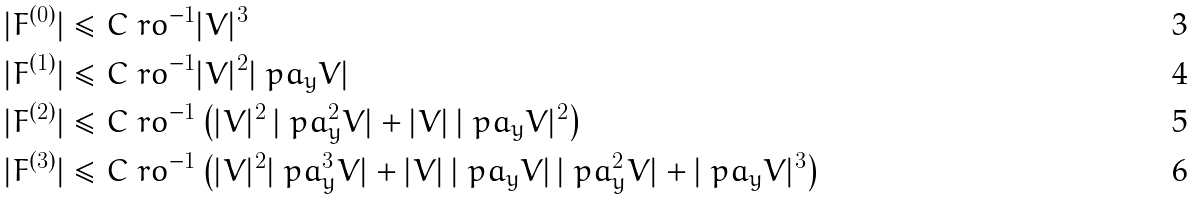<formula> <loc_0><loc_0><loc_500><loc_500>| F ^ { ( 0 ) } | & \leq C \ r o ^ { - 1 } | V | ^ { 3 } \\ | F ^ { ( 1 ) } | & \leq C \ r o ^ { - 1 } | V | ^ { 2 } | \ p a _ { y } V | \\ | F ^ { ( 2 ) } | & \leq C \ r o ^ { - 1 } \left ( | V | ^ { 2 } \, | \ p a _ { y } ^ { 2 } V | + | V | \, | \ p a _ { y } V | ^ { 2 } \right ) \\ | F ^ { ( 3 ) } | & \leq C \ r o ^ { - 1 } \left ( | V | ^ { 2 } | \ p a _ { y } ^ { 3 } V | + | V | \, | \ p a _ { y } V | \, | \ p a _ { y } ^ { 2 } V | + | \ p a _ { y } V | ^ { 3 } \right )</formula> 